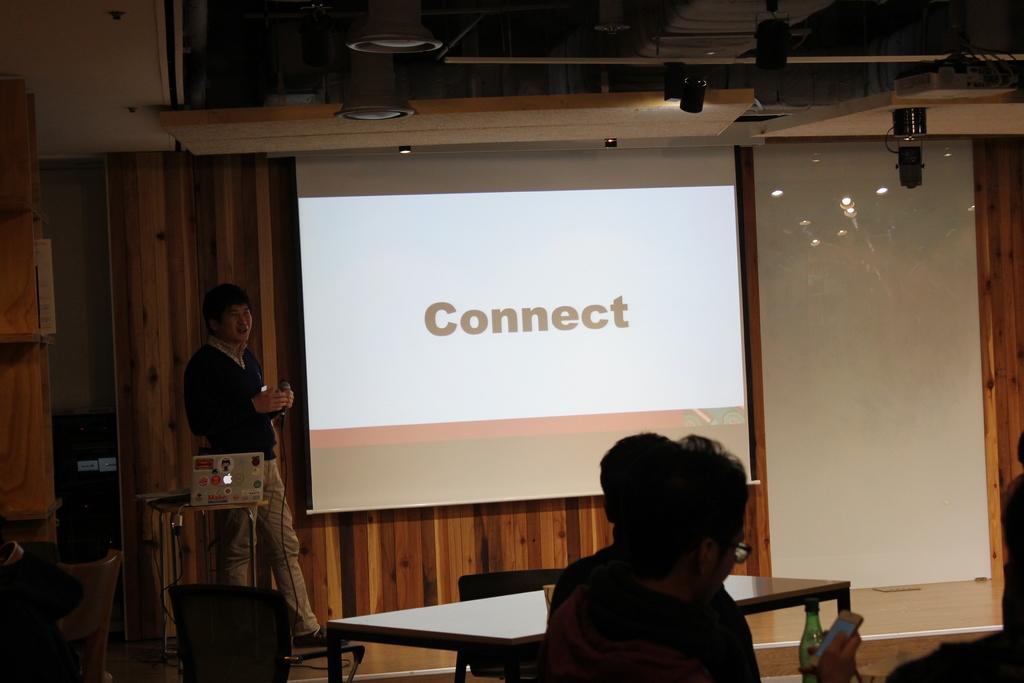Can you describe this image briefly? In this image I can see three people. Among them one person is holding the mic. To the left him there is a screen. 